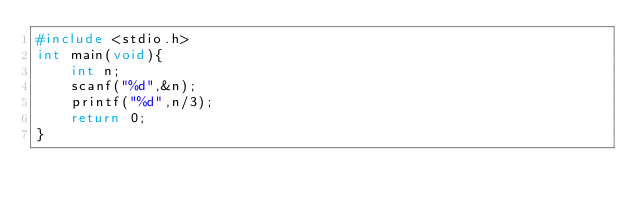<code> <loc_0><loc_0><loc_500><loc_500><_C_>#include <stdio.h>
int main(void){
    int n;
    scanf("%d",&n);
    printf("%d",n/3);
    return 0;
}</code> 